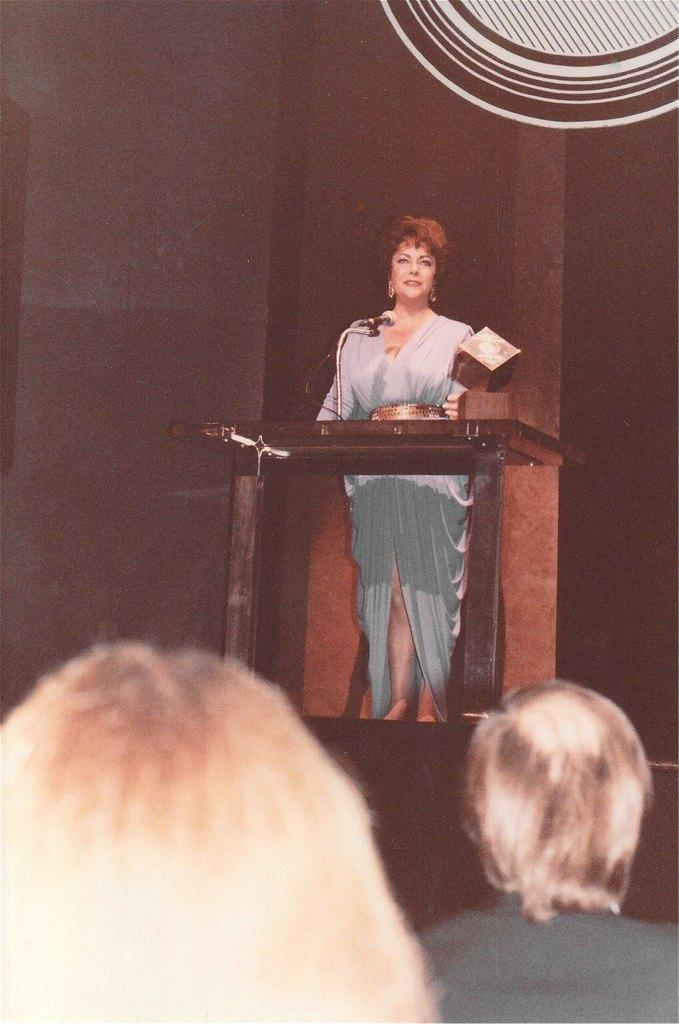What is the person in the image doing? The person is standing in front of a podium. What is behind the person? There is a wall behind the person. Are there any other people visible in the image? Yes, there are two persons at the bottom of the image. What type of jar is being used to alleviate the pain in the image? There is no jar or pain present in the image. 